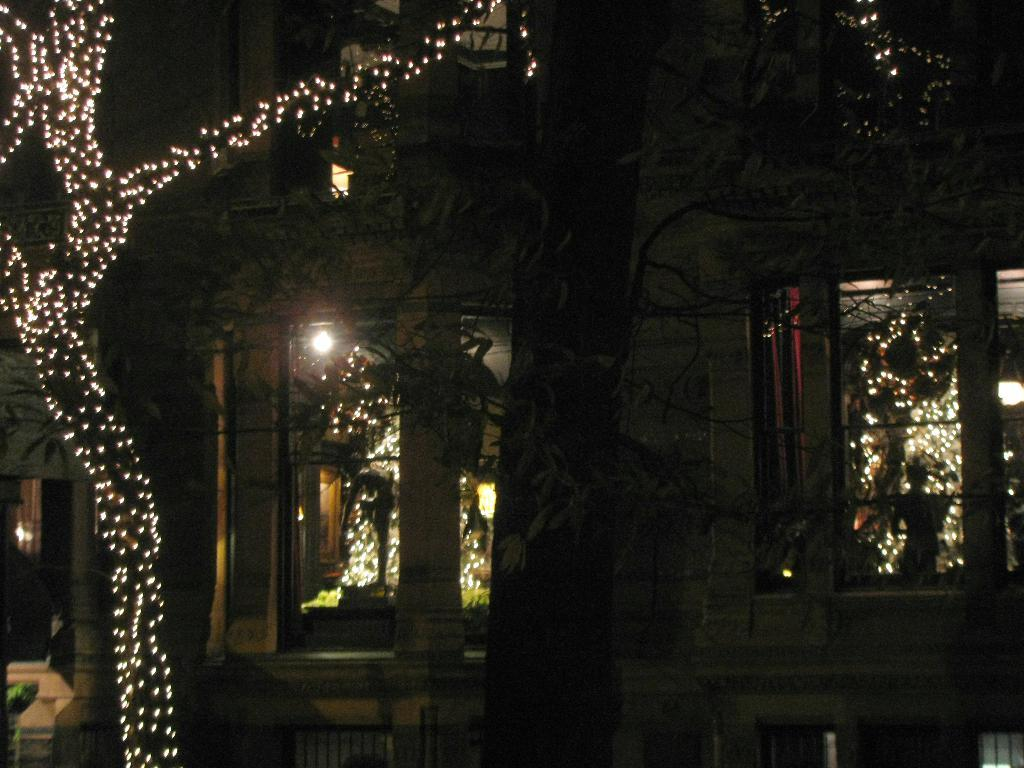What type of natural elements can be seen in the image? There are trees in the image. Can you describe a specific tree in the image? There is a tree with lights in the image. What type of structure is visible in the image? There is a building with windows in the image. What can be seen inside the building? There are lights inside the building. How many kittens are sitting on the ring in the image? There is no ring or kittens present in the image. What type of chicken can be seen walking near the tree with lights? There is no chicken present in the image; it only features trees, a tree with lights, a building, and lights inside the building. 